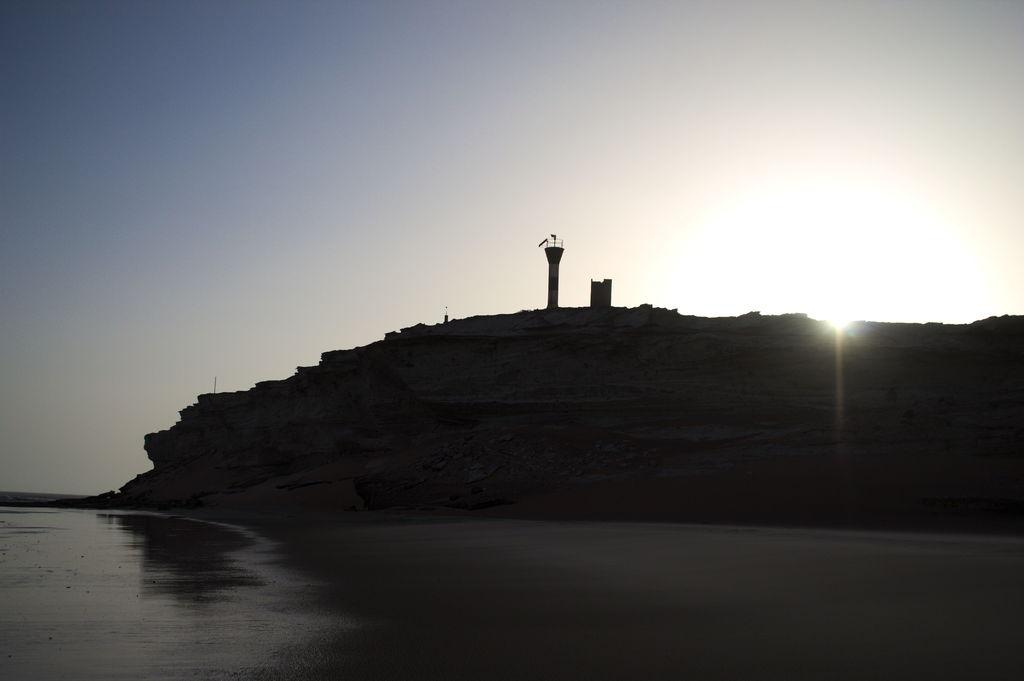What geographical feature is present in the image? There is a hill in the image. What structure is located on the hill? There is a tower on the hill. What natural element can be seen in the image? Water is visible in the image. How would you describe the weather in the image? The sky is cloudy, and sunlight is visible, suggesting a mix of clouds and sun. Can you see a toad sitting on the bread in the image? There is no bread or toad present in the image. Is there a comb visible in the image? There is no comb visible in the image. 